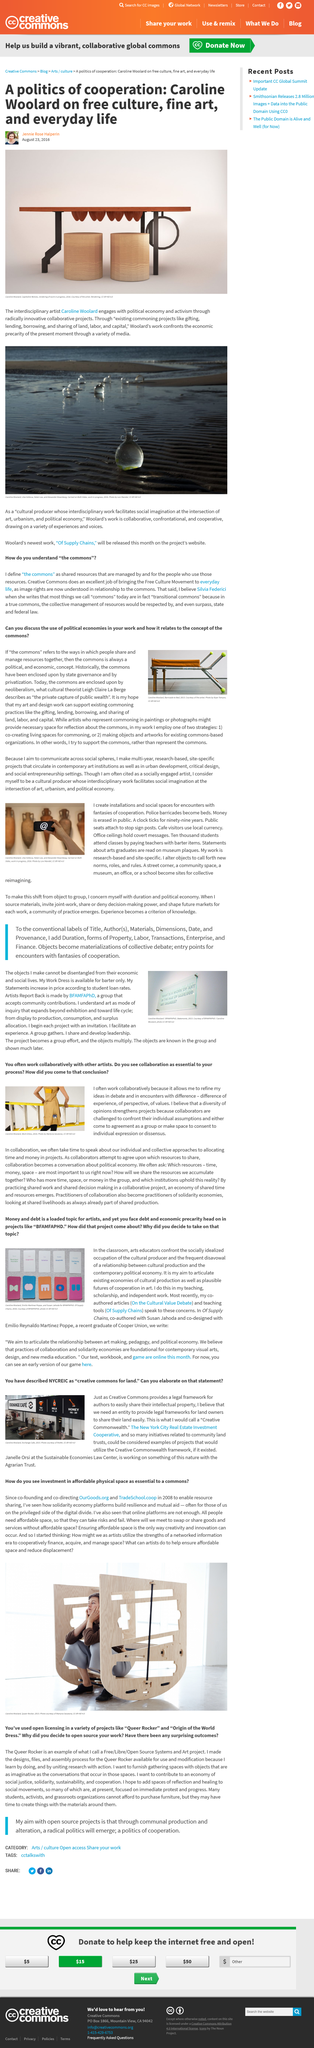Give some essential details in this illustration. The Queer Rocker is an example of an open source system. Sudan Jahoda co-authored "Supply Chains. Leigh Claire la Berge is a cultural theorist known for her contributions to the field. This article is about open source technology and its significance in the world of information technology. Caroline Wooland frequently collaborates with other artists because it enables her to refine her ideas through discussions and interactions with diverse perspectives. 